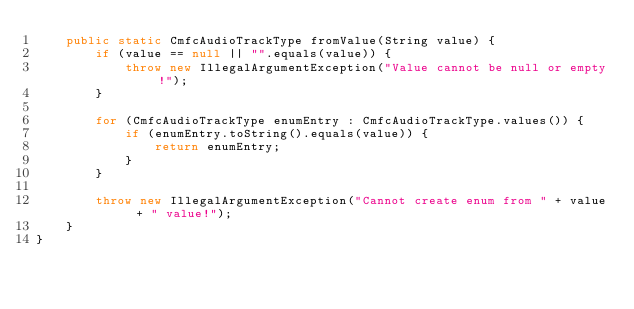<code> <loc_0><loc_0><loc_500><loc_500><_Java_>    public static CmfcAudioTrackType fromValue(String value) {
        if (value == null || "".equals(value)) {
            throw new IllegalArgumentException("Value cannot be null or empty!");
        }

        for (CmfcAudioTrackType enumEntry : CmfcAudioTrackType.values()) {
            if (enumEntry.toString().equals(value)) {
                return enumEntry;
            }
        }

        throw new IllegalArgumentException("Cannot create enum from " + value + " value!");
    }
}
</code> 